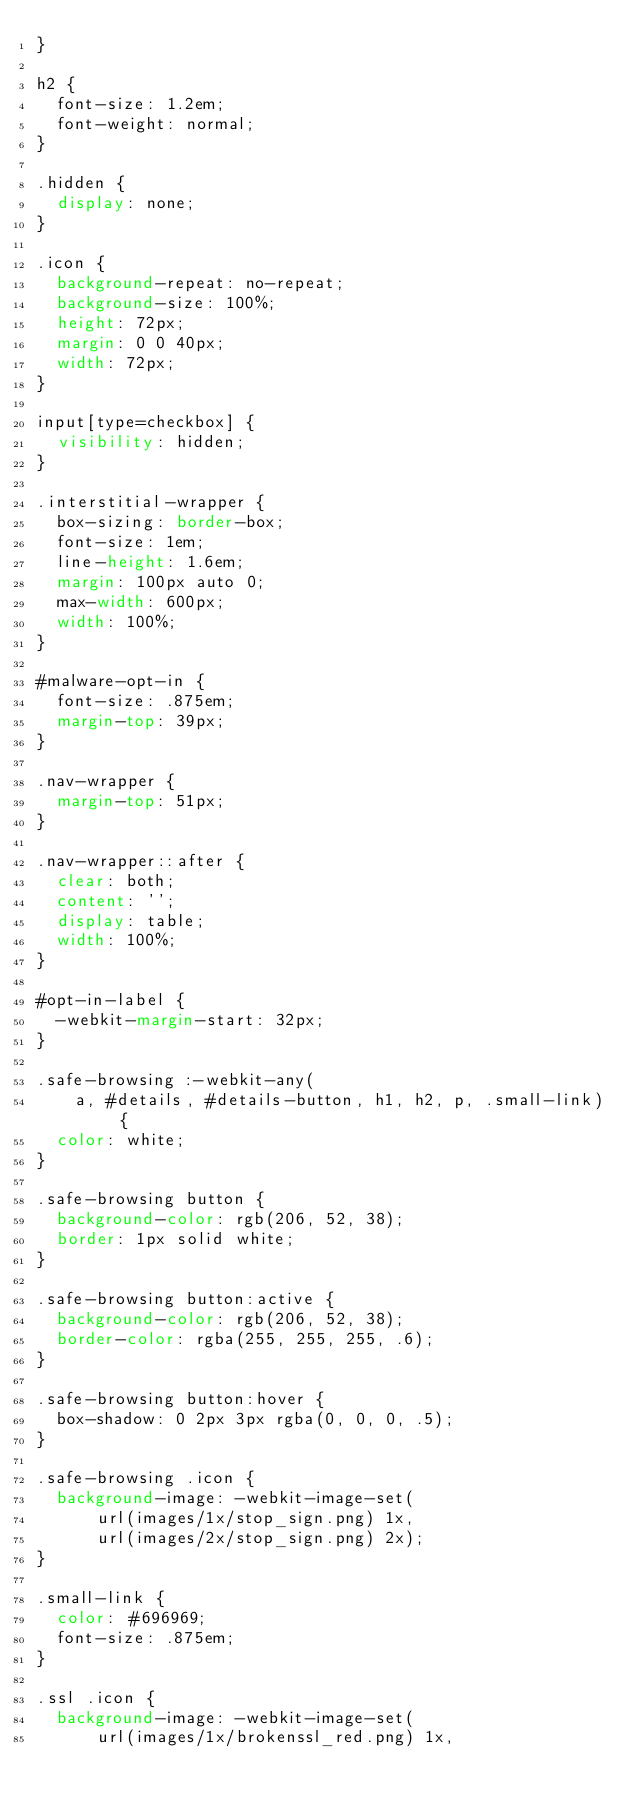Convert code to text. <code><loc_0><loc_0><loc_500><loc_500><_CSS_>}

h2 {
  font-size: 1.2em;
  font-weight: normal;
}

.hidden {
  display: none;
}

.icon {
  background-repeat: no-repeat;
  background-size: 100%;
  height: 72px;
  margin: 0 0 40px;
  width: 72px;
}

input[type=checkbox] {
  visibility: hidden;
}

.interstitial-wrapper {
  box-sizing: border-box;
  font-size: 1em;
  line-height: 1.6em;
  margin: 100px auto 0;
  max-width: 600px;
  width: 100%;
}

#malware-opt-in {
  font-size: .875em;
  margin-top: 39px;
}

.nav-wrapper {
  margin-top: 51px;
}

.nav-wrapper::after {
  clear: both;
  content: '';
  display: table;
  width: 100%;
}

#opt-in-label {
  -webkit-margin-start: 32px;
}

.safe-browsing :-webkit-any(
    a, #details, #details-button, h1, h2, p, .small-link) {
  color: white;
}

.safe-browsing button {
  background-color: rgb(206, 52, 38);
  border: 1px solid white;
}

.safe-browsing button:active {
  background-color: rgb(206, 52, 38);
  border-color: rgba(255, 255, 255, .6);
}

.safe-browsing button:hover {
  box-shadow: 0 2px 3px rgba(0, 0, 0, .5);
}

.safe-browsing .icon {
  background-image: -webkit-image-set(
      url(images/1x/stop_sign.png) 1x,
      url(images/2x/stop_sign.png) 2x);
}

.small-link {
  color: #696969;
  font-size: .875em;
}

.ssl .icon {
  background-image: -webkit-image-set(
      url(images/1x/brokenssl_red.png) 1x,</code> 